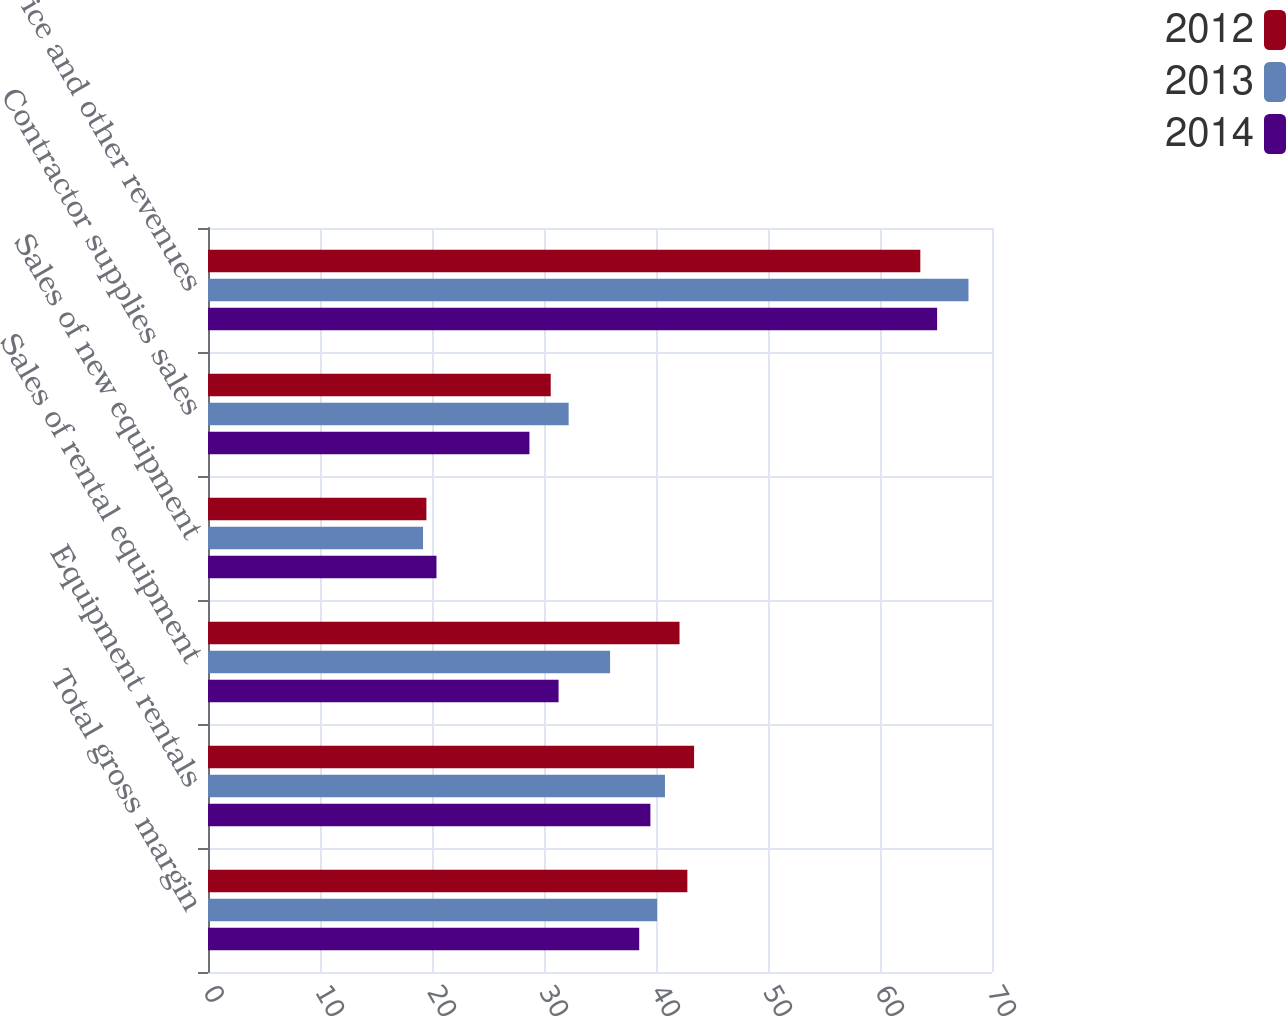<chart> <loc_0><loc_0><loc_500><loc_500><stacked_bar_chart><ecel><fcel>Total gross margin<fcel>Equipment rentals<fcel>Sales of rental equipment<fcel>Sales of new equipment<fcel>Contractor supplies sales<fcel>Service and other revenues<nl><fcel>2012<fcel>42.8<fcel>43.4<fcel>42.1<fcel>19.5<fcel>30.6<fcel>63.6<nl><fcel>2013<fcel>40.1<fcel>40.8<fcel>35.9<fcel>19.2<fcel>32.2<fcel>67.9<nl><fcel>2014<fcel>38.5<fcel>39.5<fcel>31.3<fcel>20.4<fcel>28.7<fcel>65.1<nl></chart> 